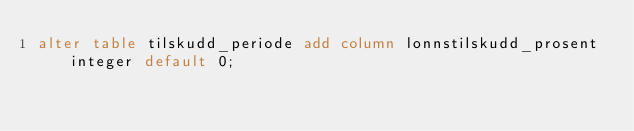<code> <loc_0><loc_0><loc_500><loc_500><_SQL_>alter table tilskudd_periode add column lonnstilskudd_prosent integer default 0;</code> 